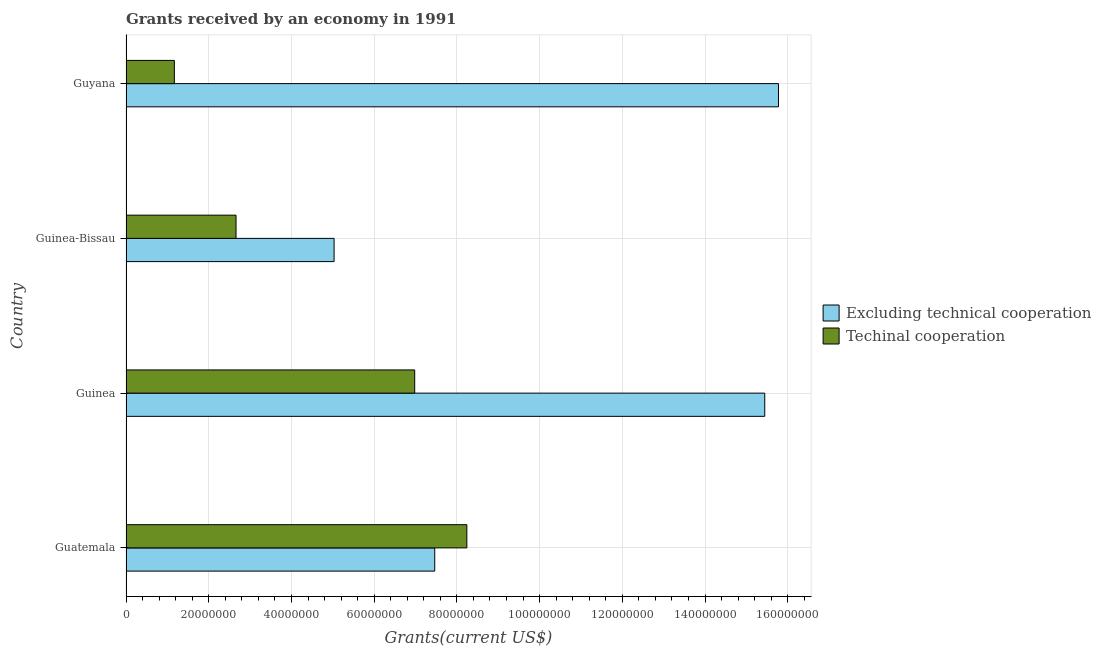How many groups of bars are there?
Provide a short and direct response. 4. Are the number of bars per tick equal to the number of legend labels?
Ensure brevity in your answer.  Yes. How many bars are there on the 4th tick from the top?
Provide a succinct answer. 2. How many bars are there on the 2nd tick from the bottom?
Give a very brief answer. 2. What is the label of the 3rd group of bars from the top?
Make the answer very short. Guinea. What is the amount of grants received(excluding technical cooperation) in Guatemala?
Your answer should be compact. 7.46e+07. Across all countries, what is the maximum amount of grants received(excluding technical cooperation)?
Your answer should be compact. 1.58e+08. Across all countries, what is the minimum amount of grants received(excluding technical cooperation)?
Provide a succinct answer. 5.03e+07. In which country was the amount of grants received(including technical cooperation) maximum?
Ensure brevity in your answer.  Guatemala. In which country was the amount of grants received(including technical cooperation) minimum?
Your response must be concise. Guyana. What is the total amount of grants received(including technical cooperation) in the graph?
Provide a succinct answer. 1.90e+08. What is the difference between the amount of grants received(including technical cooperation) in Guinea and that in Guinea-Bissau?
Provide a succinct answer. 4.32e+07. What is the difference between the amount of grants received(excluding technical cooperation) in Guatemala and the amount of grants received(including technical cooperation) in Guyana?
Provide a succinct answer. 6.30e+07. What is the average amount of grants received(excluding technical cooperation) per country?
Give a very brief answer. 1.09e+08. What is the difference between the amount of grants received(including technical cooperation) and amount of grants received(excluding technical cooperation) in Guinea-Bissau?
Provide a short and direct response. -2.37e+07. In how many countries, is the amount of grants received(including technical cooperation) greater than 52000000 US$?
Give a very brief answer. 2. What is the ratio of the amount of grants received(excluding technical cooperation) in Guinea-Bissau to that in Guyana?
Provide a succinct answer. 0.32. What is the difference between the highest and the second highest amount of grants received(including technical cooperation)?
Ensure brevity in your answer.  1.26e+07. What is the difference between the highest and the lowest amount of grants received(including technical cooperation)?
Provide a succinct answer. 7.07e+07. Is the sum of the amount of grants received(excluding technical cooperation) in Guinea and Guyana greater than the maximum amount of grants received(including technical cooperation) across all countries?
Your response must be concise. Yes. What does the 2nd bar from the top in Guyana represents?
Provide a short and direct response. Excluding technical cooperation. What does the 2nd bar from the bottom in Guatemala represents?
Your answer should be compact. Techinal cooperation. Are all the bars in the graph horizontal?
Provide a succinct answer. Yes. Does the graph contain any zero values?
Make the answer very short. No. How many legend labels are there?
Keep it short and to the point. 2. What is the title of the graph?
Make the answer very short. Grants received by an economy in 1991. Does "Chemicals" appear as one of the legend labels in the graph?
Make the answer very short. No. What is the label or title of the X-axis?
Ensure brevity in your answer.  Grants(current US$). What is the Grants(current US$) in Excluding technical cooperation in Guatemala?
Give a very brief answer. 7.46e+07. What is the Grants(current US$) of Techinal cooperation in Guatemala?
Provide a succinct answer. 8.24e+07. What is the Grants(current US$) of Excluding technical cooperation in Guinea?
Your answer should be compact. 1.54e+08. What is the Grants(current US$) of Techinal cooperation in Guinea?
Offer a very short reply. 6.98e+07. What is the Grants(current US$) in Excluding technical cooperation in Guinea-Bissau?
Offer a very short reply. 5.03e+07. What is the Grants(current US$) of Techinal cooperation in Guinea-Bissau?
Your answer should be very brief. 2.66e+07. What is the Grants(current US$) of Excluding technical cooperation in Guyana?
Your answer should be very brief. 1.58e+08. What is the Grants(current US$) in Techinal cooperation in Guyana?
Offer a terse response. 1.17e+07. Across all countries, what is the maximum Grants(current US$) in Excluding technical cooperation?
Give a very brief answer. 1.58e+08. Across all countries, what is the maximum Grants(current US$) in Techinal cooperation?
Your response must be concise. 8.24e+07. Across all countries, what is the minimum Grants(current US$) of Excluding technical cooperation?
Your answer should be compact. 5.03e+07. Across all countries, what is the minimum Grants(current US$) of Techinal cooperation?
Ensure brevity in your answer.  1.17e+07. What is the total Grants(current US$) in Excluding technical cooperation in the graph?
Keep it short and to the point. 4.37e+08. What is the total Grants(current US$) of Techinal cooperation in the graph?
Your answer should be very brief. 1.90e+08. What is the difference between the Grants(current US$) of Excluding technical cooperation in Guatemala and that in Guinea?
Ensure brevity in your answer.  -7.98e+07. What is the difference between the Grants(current US$) in Techinal cooperation in Guatemala and that in Guinea?
Your answer should be very brief. 1.26e+07. What is the difference between the Grants(current US$) in Excluding technical cooperation in Guatemala and that in Guinea-Bissau?
Make the answer very short. 2.43e+07. What is the difference between the Grants(current US$) in Techinal cooperation in Guatemala and that in Guinea-Bissau?
Your answer should be very brief. 5.58e+07. What is the difference between the Grants(current US$) of Excluding technical cooperation in Guatemala and that in Guyana?
Provide a short and direct response. -8.31e+07. What is the difference between the Grants(current US$) in Techinal cooperation in Guatemala and that in Guyana?
Your answer should be very brief. 7.07e+07. What is the difference between the Grants(current US$) in Excluding technical cooperation in Guinea and that in Guinea-Bissau?
Ensure brevity in your answer.  1.04e+08. What is the difference between the Grants(current US$) in Techinal cooperation in Guinea and that in Guinea-Bissau?
Provide a short and direct response. 4.32e+07. What is the difference between the Grants(current US$) in Excluding technical cooperation in Guinea and that in Guyana?
Your response must be concise. -3.32e+06. What is the difference between the Grants(current US$) of Techinal cooperation in Guinea and that in Guyana?
Provide a short and direct response. 5.81e+07. What is the difference between the Grants(current US$) in Excluding technical cooperation in Guinea-Bissau and that in Guyana?
Offer a terse response. -1.07e+08. What is the difference between the Grants(current US$) of Techinal cooperation in Guinea-Bissau and that in Guyana?
Offer a very short reply. 1.49e+07. What is the difference between the Grants(current US$) of Excluding technical cooperation in Guatemala and the Grants(current US$) of Techinal cooperation in Guinea?
Make the answer very short. 4.84e+06. What is the difference between the Grants(current US$) of Excluding technical cooperation in Guatemala and the Grants(current US$) of Techinal cooperation in Guinea-Bissau?
Give a very brief answer. 4.80e+07. What is the difference between the Grants(current US$) of Excluding technical cooperation in Guatemala and the Grants(current US$) of Techinal cooperation in Guyana?
Offer a terse response. 6.30e+07. What is the difference between the Grants(current US$) of Excluding technical cooperation in Guinea and the Grants(current US$) of Techinal cooperation in Guinea-Bissau?
Your answer should be very brief. 1.28e+08. What is the difference between the Grants(current US$) in Excluding technical cooperation in Guinea and the Grants(current US$) in Techinal cooperation in Guyana?
Ensure brevity in your answer.  1.43e+08. What is the difference between the Grants(current US$) in Excluding technical cooperation in Guinea-Bissau and the Grants(current US$) in Techinal cooperation in Guyana?
Give a very brief answer. 3.86e+07. What is the average Grants(current US$) in Excluding technical cooperation per country?
Provide a short and direct response. 1.09e+08. What is the average Grants(current US$) in Techinal cooperation per country?
Offer a terse response. 4.76e+07. What is the difference between the Grants(current US$) of Excluding technical cooperation and Grants(current US$) of Techinal cooperation in Guatemala?
Provide a succinct answer. -7.77e+06. What is the difference between the Grants(current US$) in Excluding technical cooperation and Grants(current US$) in Techinal cooperation in Guinea?
Your response must be concise. 8.46e+07. What is the difference between the Grants(current US$) of Excluding technical cooperation and Grants(current US$) of Techinal cooperation in Guinea-Bissau?
Your answer should be very brief. 2.37e+07. What is the difference between the Grants(current US$) in Excluding technical cooperation and Grants(current US$) in Techinal cooperation in Guyana?
Provide a succinct answer. 1.46e+08. What is the ratio of the Grants(current US$) of Excluding technical cooperation in Guatemala to that in Guinea?
Your answer should be very brief. 0.48. What is the ratio of the Grants(current US$) in Techinal cooperation in Guatemala to that in Guinea?
Your answer should be compact. 1.18. What is the ratio of the Grants(current US$) in Excluding technical cooperation in Guatemala to that in Guinea-Bissau?
Keep it short and to the point. 1.48. What is the ratio of the Grants(current US$) of Techinal cooperation in Guatemala to that in Guinea-Bissau?
Provide a succinct answer. 3.1. What is the ratio of the Grants(current US$) in Excluding technical cooperation in Guatemala to that in Guyana?
Provide a succinct answer. 0.47. What is the ratio of the Grants(current US$) in Techinal cooperation in Guatemala to that in Guyana?
Keep it short and to the point. 7.05. What is the ratio of the Grants(current US$) in Excluding technical cooperation in Guinea to that in Guinea-Bissau?
Give a very brief answer. 3.07. What is the ratio of the Grants(current US$) in Techinal cooperation in Guinea to that in Guinea-Bissau?
Your answer should be very brief. 2.62. What is the ratio of the Grants(current US$) in Excluding technical cooperation in Guinea to that in Guyana?
Your answer should be compact. 0.98. What is the ratio of the Grants(current US$) in Techinal cooperation in Guinea to that in Guyana?
Your response must be concise. 5.97. What is the ratio of the Grants(current US$) of Excluding technical cooperation in Guinea-Bissau to that in Guyana?
Provide a short and direct response. 0.32. What is the ratio of the Grants(current US$) of Techinal cooperation in Guinea-Bissau to that in Guyana?
Provide a succinct answer. 2.28. What is the difference between the highest and the second highest Grants(current US$) in Excluding technical cooperation?
Your answer should be compact. 3.32e+06. What is the difference between the highest and the second highest Grants(current US$) in Techinal cooperation?
Your answer should be compact. 1.26e+07. What is the difference between the highest and the lowest Grants(current US$) in Excluding technical cooperation?
Give a very brief answer. 1.07e+08. What is the difference between the highest and the lowest Grants(current US$) in Techinal cooperation?
Offer a terse response. 7.07e+07. 